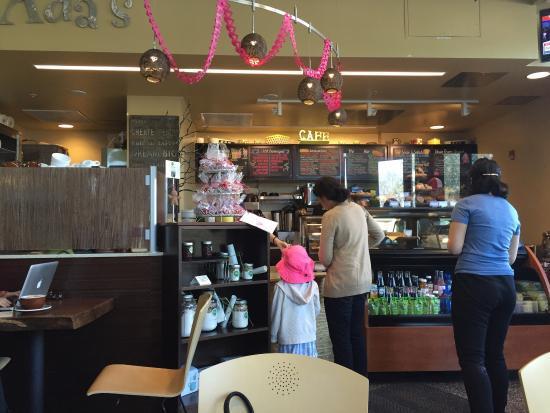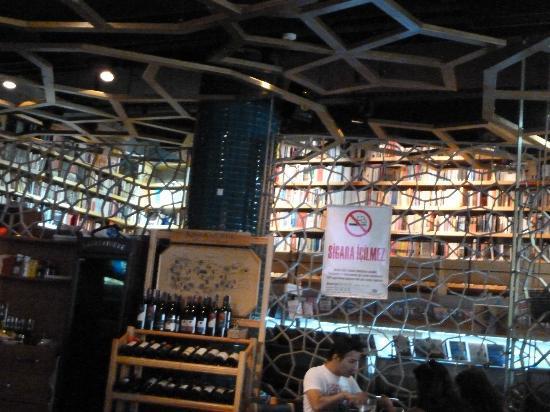The first image is the image on the left, the second image is the image on the right. Considering the images on both sides, is "The right image shows the interior of a restaurant with cone-shaped light fixtures on a ceiling with suspended circles containing geometric patterns that repeat on the right wall." valid? Answer yes or no. No. The first image is the image on the left, the second image is the image on the right. Considering the images on both sides, is "In at least one image there is no more than one person in a wine and book shop." valid? Answer yes or no. Yes. 